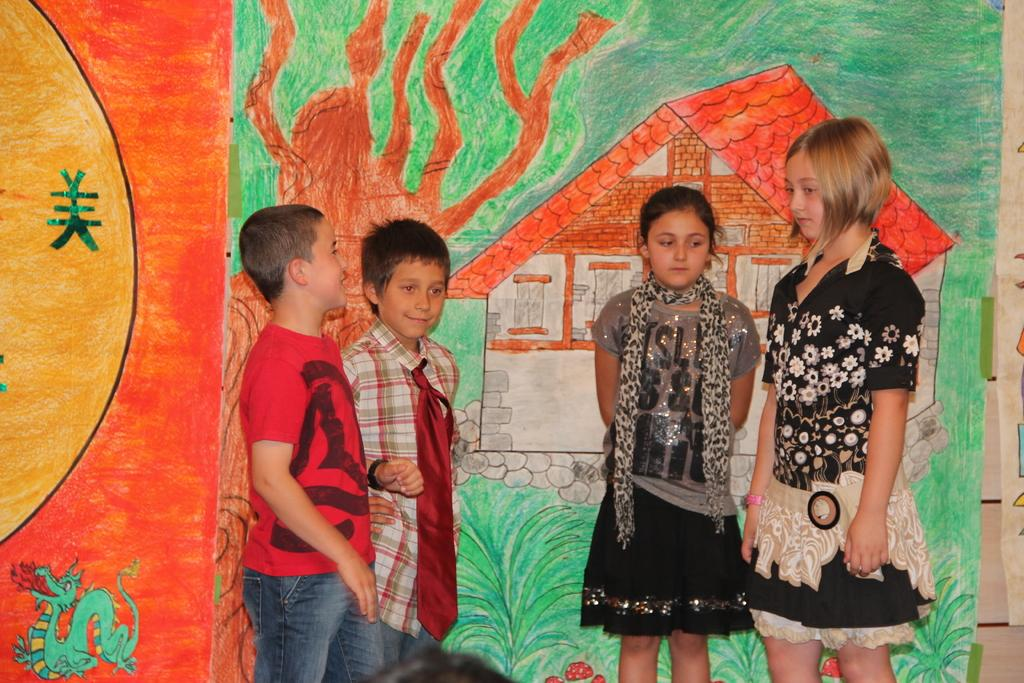What is the main subject of the image? The main subject of the image is a group of children standing. What can be seen in the background of the image? There is a drawing of a house in the image. What elements are included in the drawing? The drawing includes the sun, plants, a tree, and an animal. What type of canvas is the animal sitting on in the image? There is no canvas present in the image, and the animal is not sitting on any surface. The animal is part of the drawing of the house. 